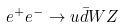<formula> <loc_0><loc_0><loc_500><loc_500>e ^ { + } e ^ { - } \rightarrow u \bar { d } W Z</formula> 